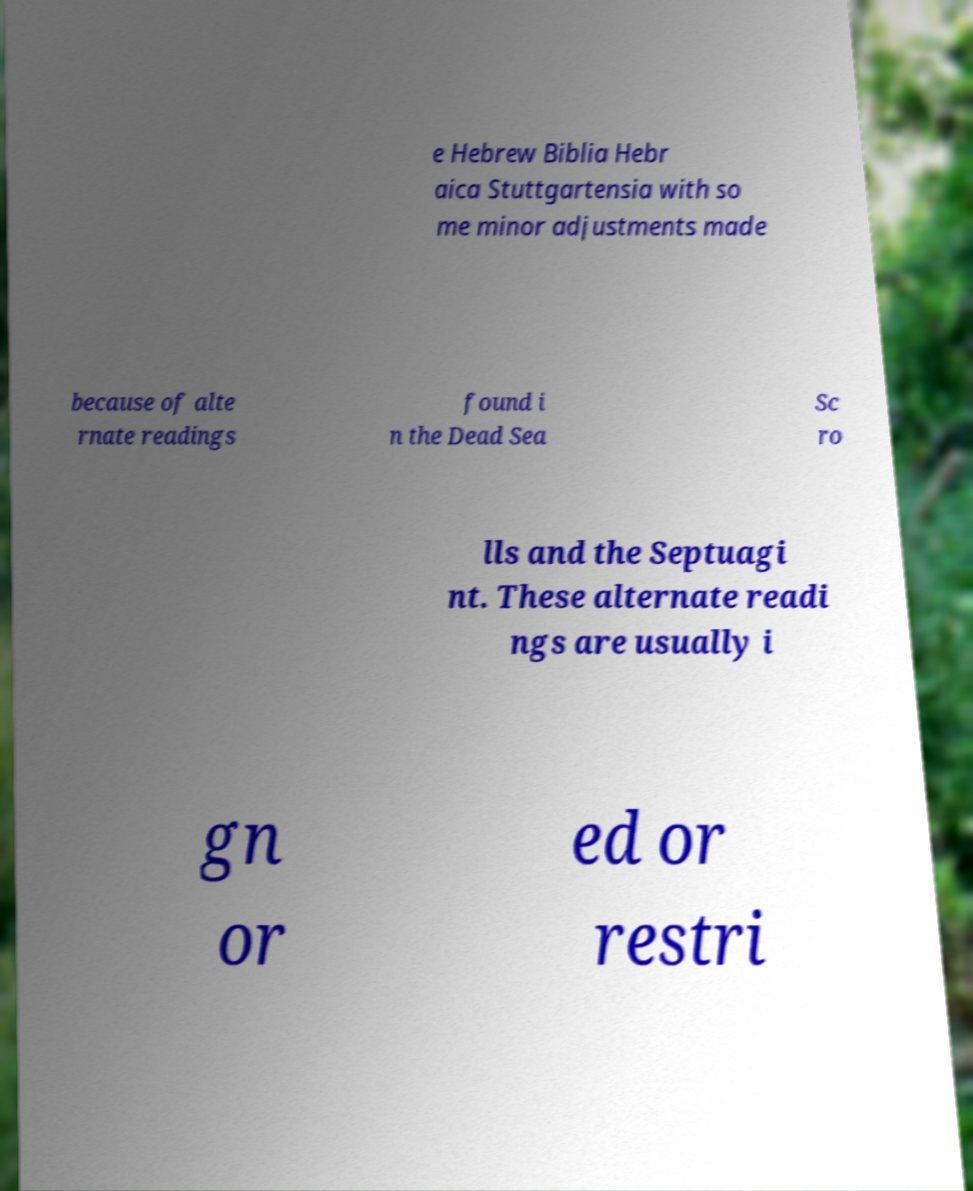For documentation purposes, I need the text within this image transcribed. Could you provide that? e Hebrew Biblia Hebr aica Stuttgartensia with so me minor adjustments made because of alte rnate readings found i n the Dead Sea Sc ro lls and the Septuagi nt. These alternate readi ngs are usually i gn or ed or restri 